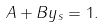Convert formula to latex. <formula><loc_0><loc_0><loc_500><loc_500>A + B y _ { s } = 1 .</formula> 